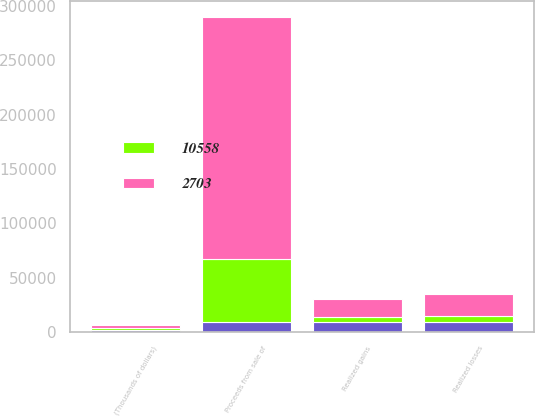<chart> <loc_0><loc_0><loc_500><loc_500><stacked_bar_chart><ecel><fcel>(Thousands of dollars)<fcel>Realized gains<fcel>Realized losses<fcel>Proceeds from sale of<nl><fcel>nan<fcel>2005<fcel>8967<fcel>8990<fcel>8967<nl><fcel>2703<fcel>2004<fcel>16578<fcel>20180<fcel>223135<nl><fcel>10558<fcel>2003<fcel>4999<fcel>6025<fcel>57768<nl></chart> 